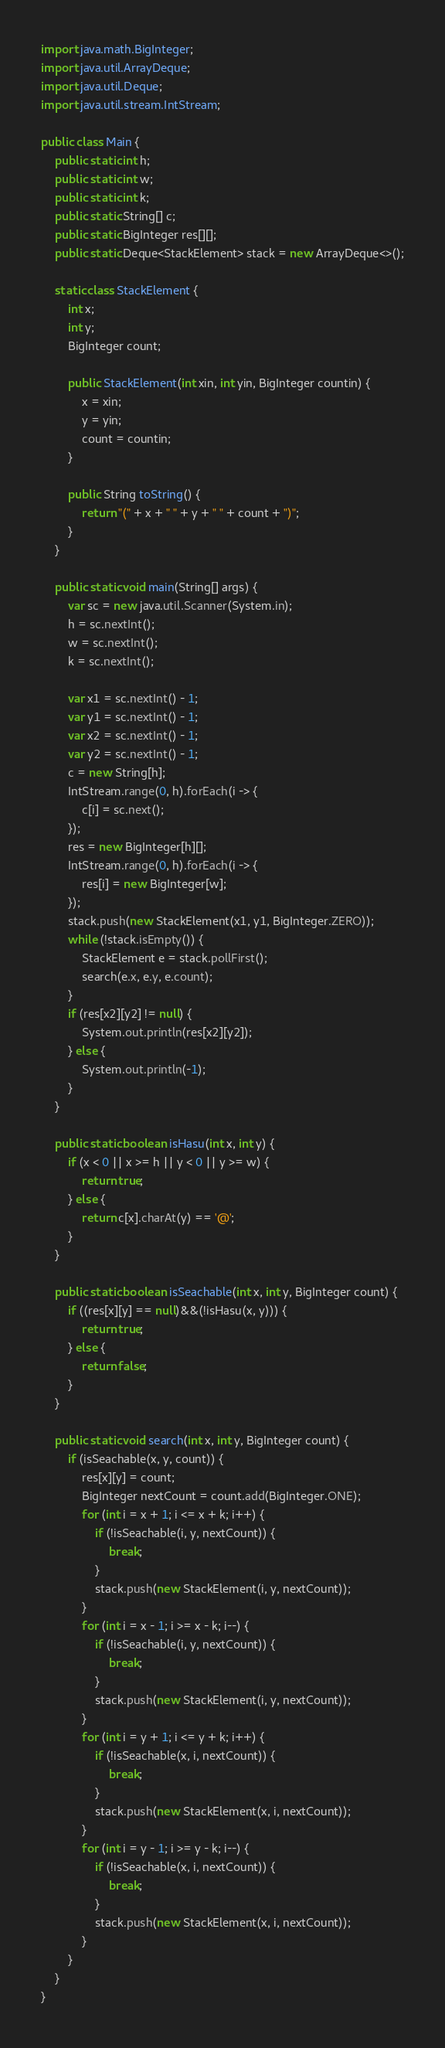<code> <loc_0><loc_0><loc_500><loc_500><_Java_>import java.math.BigInteger;
import java.util.ArrayDeque;
import java.util.Deque;
import java.util.stream.IntStream;

public class Main {
	public static int h;
	public static int w;
	public static int k;
	public static String[] c;
	public static BigInteger res[][];
	public static Deque<StackElement> stack = new ArrayDeque<>();

	static class StackElement {
		int x;
		int y;
		BigInteger count;

		public StackElement(int xin, int yin, BigInteger countin) {
			x = xin;
			y = yin;
			count = countin;
		}

		public String toString() {
			return "(" + x + " " + y + " " + count + ")";
		}
	}

	public static void main(String[] args) {
		var sc = new java.util.Scanner(System.in);
		h = sc.nextInt();
		w = sc.nextInt();
		k = sc.nextInt();

		var x1 = sc.nextInt() - 1;
		var y1 = sc.nextInt() - 1;
		var x2 = sc.nextInt() - 1;
		var y2 = sc.nextInt() - 1;
		c = new String[h];
		IntStream.range(0, h).forEach(i -> {
			c[i] = sc.next();
		});
		res = new BigInteger[h][];
		IntStream.range(0, h).forEach(i -> {
			res[i] = new BigInteger[w];
		});
		stack.push(new StackElement(x1, y1, BigInteger.ZERO));
		while (!stack.isEmpty()) {
			StackElement e = stack.pollFirst();
			search(e.x, e.y, e.count);
		}
		if (res[x2][y2] != null) {
			System.out.println(res[x2][y2]);
		} else {
			System.out.println(-1);
		}
	}

	public static boolean isHasu(int x, int y) {
		if (x < 0 || x >= h || y < 0 || y >= w) {
			return true;
		} else {
			return c[x].charAt(y) == '@';
		}
	}

	public static boolean isSeachable(int x, int y, BigInteger count) {
		if ((res[x][y] == null)&&(!isHasu(x, y))) {
			return true;
		} else {
			return false;
		}
	}

	public static void search(int x, int y, BigInteger count) {
		if (isSeachable(x, y, count)) {
			res[x][y] = count;
			BigInteger nextCount = count.add(BigInteger.ONE);
			for (int i = x + 1; i <= x + k; i++) {
				if (!isSeachable(i, y, nextCount)) {
					break;
				}
				stack.push(new StackElement(i, y, nextCount));
			}
			for (int i = x - 1; i >= x - k; i--) {
				if (!isSeachable(i, y, nextCount)) {
					break;
				}
				stack.push(new StackElement(i, y, nextCount));
			}
			for (int i = y + 1; i <= y + k; i++) {
				if (!isSeachable(x, i, nextCount)) {
					break;
				}
				stack.push(new StackElement(x, i, nextCount));
			}
			for (int i = y - 1; i >= y - k; i--) {
				if (!isSeachable(x, i, nextCount)) {
					break;
				}
				stack.push(new StackElement(x, i, nextCount));
			}
		}
	}
}</code> 